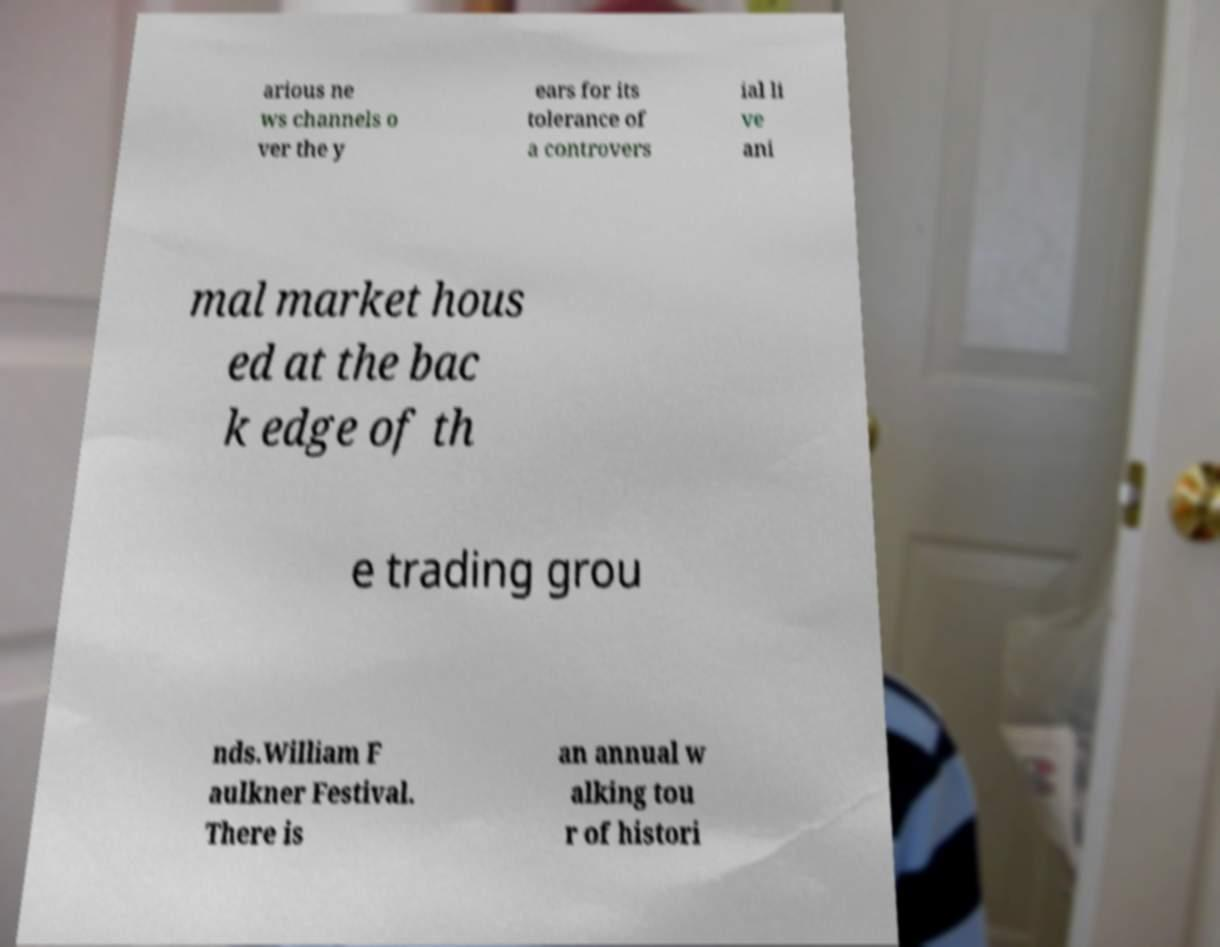Could you extract and type out the text from this image? arious ne ws channels o ver the y ears for its tolerance of a controvers ial li ve ani mal market hous ed at the bac k edge of th e trading grou nds.William F aulkner Festival. There is an annual w alking tou r of histori 